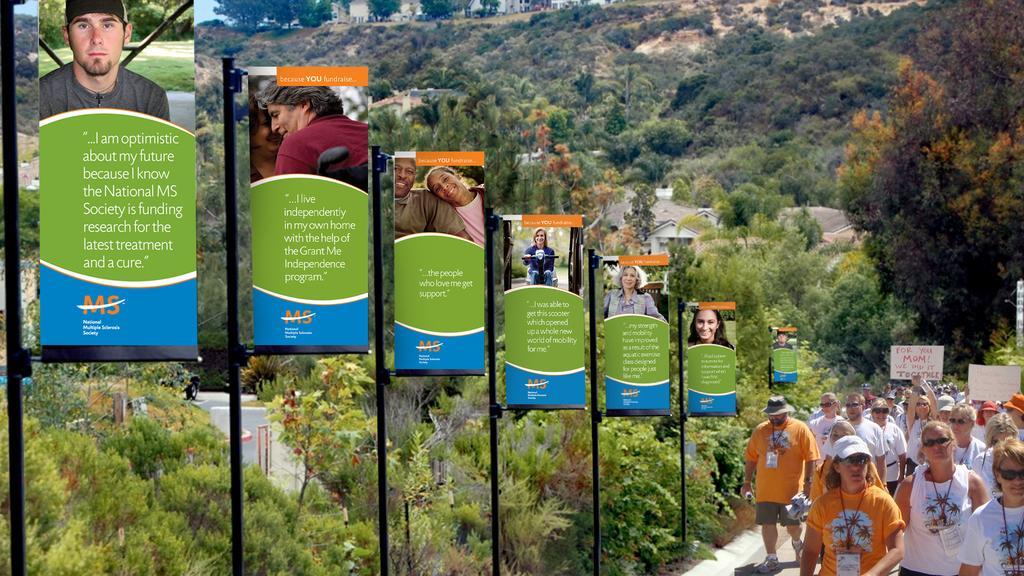Describe this image in one or two sentences. In this image we can see a few people and holding the written text boards, on the left we can see some written text on the board, metal poles, there are few trees, plants, hills, we can see the houses, at the top we can see the sky. 